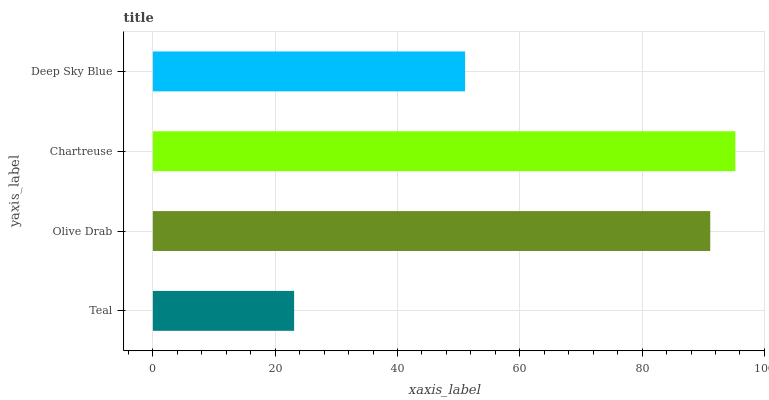Is Teal the minimum?
Answer yes or no. Yes. Is Chartreuse the maximum?
Answer yes or no. Yes. Is Olive Drab the minimum?
Answer yes or no. No. Is Olive Drab the maximum?
Answer yes or no. No. Is Olive Drab greater than Teal?
Answer yes or no. Yes. Is Teal less than Olive Drab?
Answer yes or no. Yes. Is Teal greater than Olive Drab?
Answer yes or no. No. Is Olive Drab less than Teal?
Answer yes or no. No. Is Olive Drab the high median?
Answer yes or no. Yes. Is Deep Sky Blue the low median?
Answer yes or no. Yes. Is Teal the high median?
Answer yes or no. No. Is Olive Drab the low median?
Answer yes or no. No. 